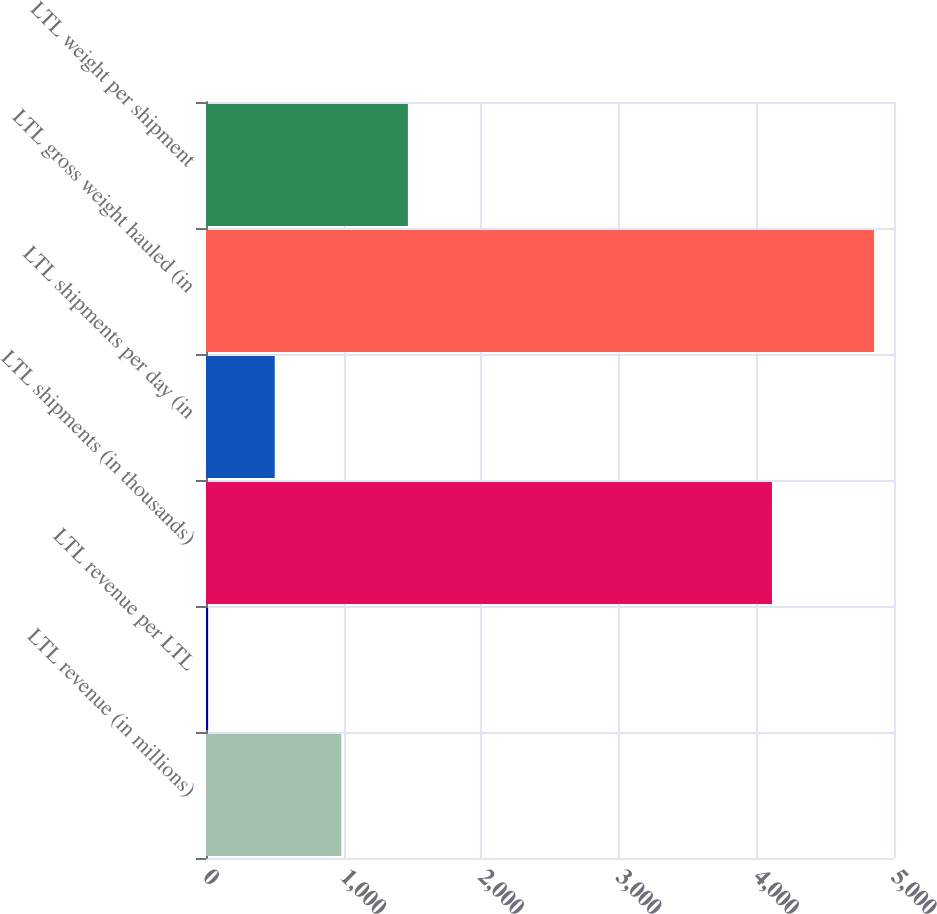Convert chart. <chart><loc_0><loc_0><loc_500><loc_500><bar_chart><fcel>LTL revenue (in millions)<fcel>LTL revenue per LTL<fcel>LTL shipments (in thousands)<fcel>LTL shipments per day (in<fcel>LTL gross weight hauled (in<fcel>LTL weight per shipment<nl><fcel>983.43<fcel>15.53<fcel>4113<fcel>499.48<fcel>4855<fcel>1467.38<nl></chart> 